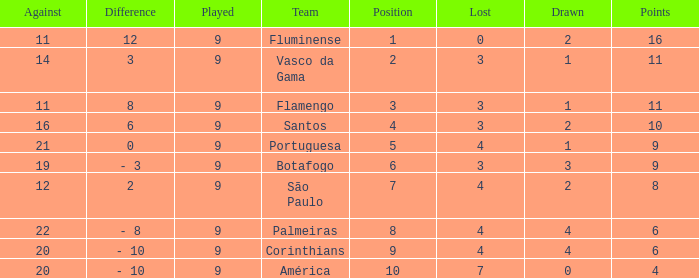Which Against is the highest one that has a Difference of 12? 11.0. 